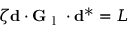<formula> <loc_0><loc_0><loc_500><loc_500>\zeta d \cdot G _ { l } \cdot d ^ { * } = L</formula> 